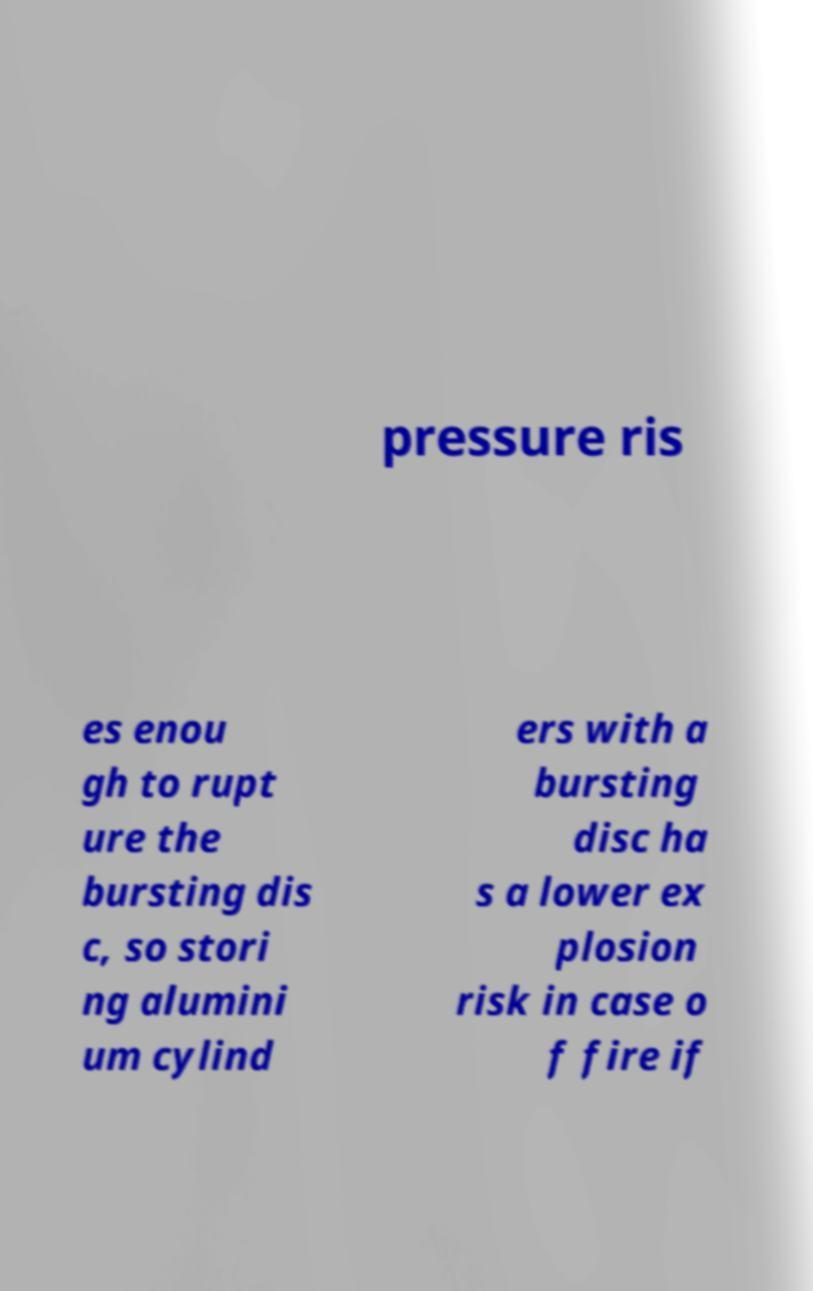Could you assist in decoding the text presented in this image and type it out clearly? pressure ris es enou gh to rupt ure the bursting dis c, so stori ng alumini um cylind ers with a bursting disc ha s a lower ex plosion risk in case o f fire if 